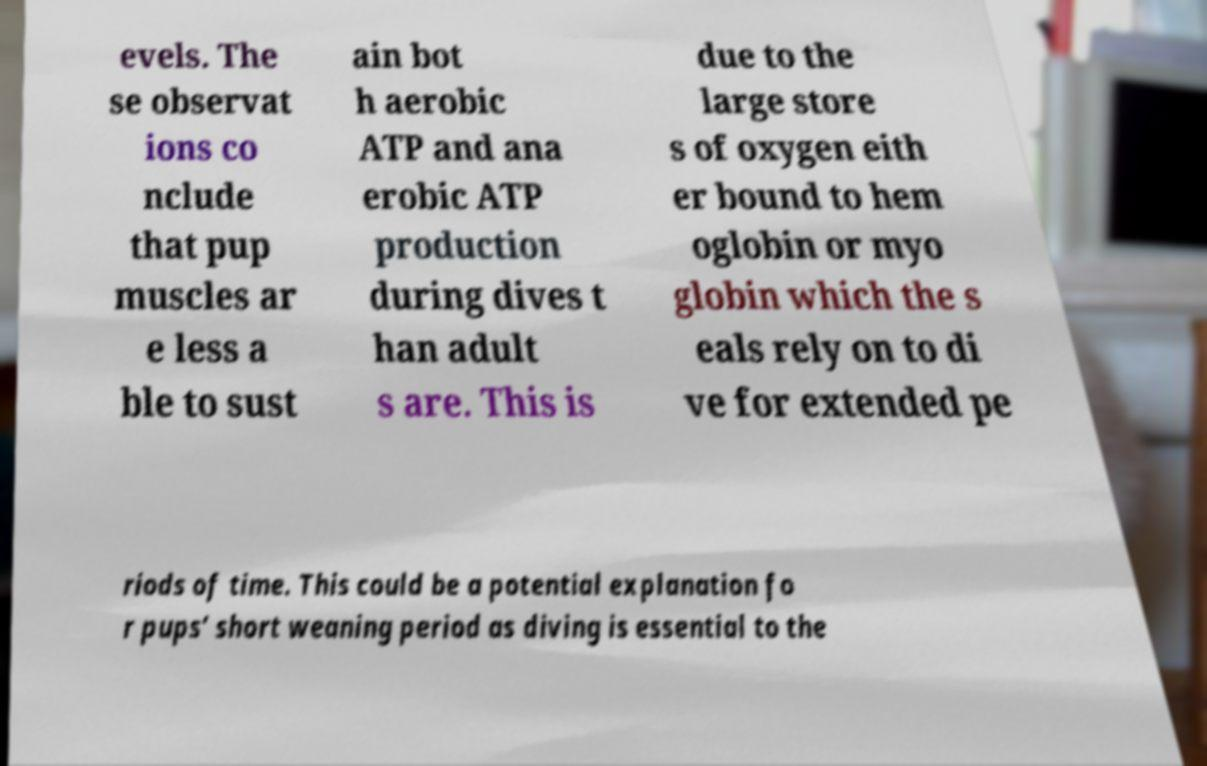Can you read and provide the text displayed in the image?This photo seems to have some interesting text. Can you extract and type it out for me? evels. The se observat ions co nclude that pup muscles ar e less a ble to sust ain bot h aerobic ATP and ana erobic ATP production during dives t han adult s are. This is due to the large store s of oxygen eith er bound to hem oglobin or myo globin which the s eals rely on to di ve for extended pe riods of time. This could be a potential explanation fo r pups’ short weaning period as diving is essential to the 